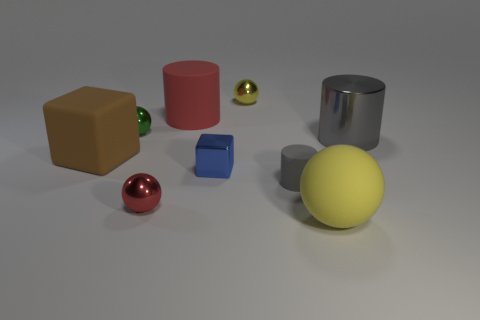What number of small things are purple matte objects or metallic cubes?
Offer a terse response. 1. What shape is the thing that is both on the right side of the blue cube and behind the small green shiny ball?
Provide a short and direct response. Sphere. Are the small green object and the tiny yellow sphere made of the same material?
Provide a succinct answer. Yes. There is a matte ball that is the same size as the brown rubber thing; what is its color?
Your response must be concise. Yellow. There is a cylinder that is both on the left side of the big yellow thing and right of the small yellow shiny ball; what is its color?
Offer a very short reply. Gray. There is a metal cylinder that is the same color as the small matte cylinder; what is its size?
Keep it short and to the point. Large. What is the shape of the thing that is the same color as the matte ball?
Your answer should be compact. Sphere. How big is the red object that is behind the cube that is on the right side of the large brown rubber object to the left of the matte sphere?
Provide a short and direct response. Large. What material is the green object?
Your answer should be very brief. Metal. Is the material of the tiny blue block the same as the tiny ball in front of the metal cylinder?
Provide a succinct answer. Yes. 